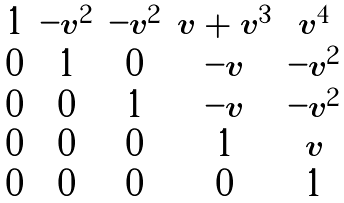<formula> <loc_0><loc_0><loc_500><loc_500>\begin{matrix} 1 & - v ^ { 2 } & - v ^ { 2 } & v + v ^ { 3 } & v ^ { 4 } \\ 0 & 1 & 0 & - v & - v ^ { 2 } \\ 0 & 0 & 1 & - v & - v ^ { 2 } \\ 0 & 0 & 0 & 1 & v \\ 0 & 0 & 0 & 0 & 1 \end{matrix}</formula> 